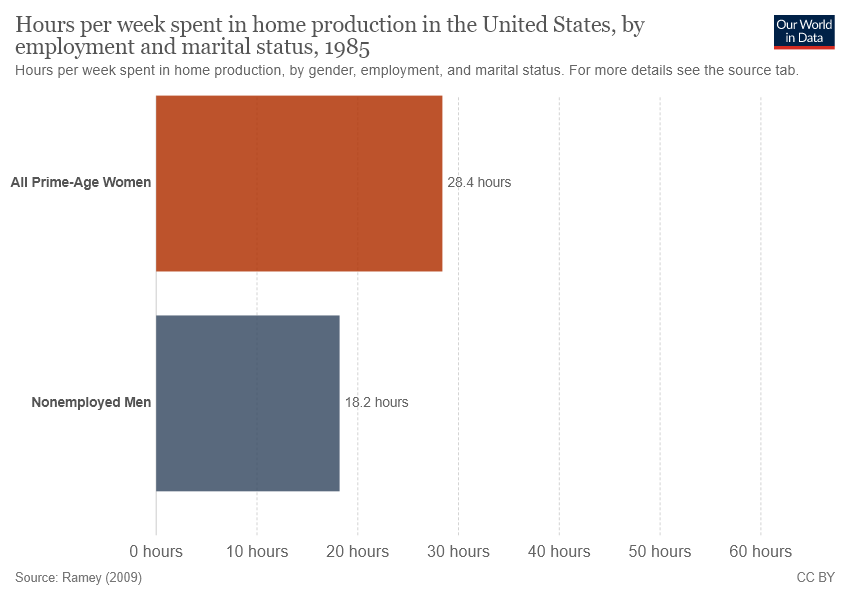Point out several critical features in this image. The difference between "AllPrime -Age Women" and "Non employed Men" is 10.2%. The study found that approximately 28.4 hours are spent by all prime age women on TGIRP activities per week. 